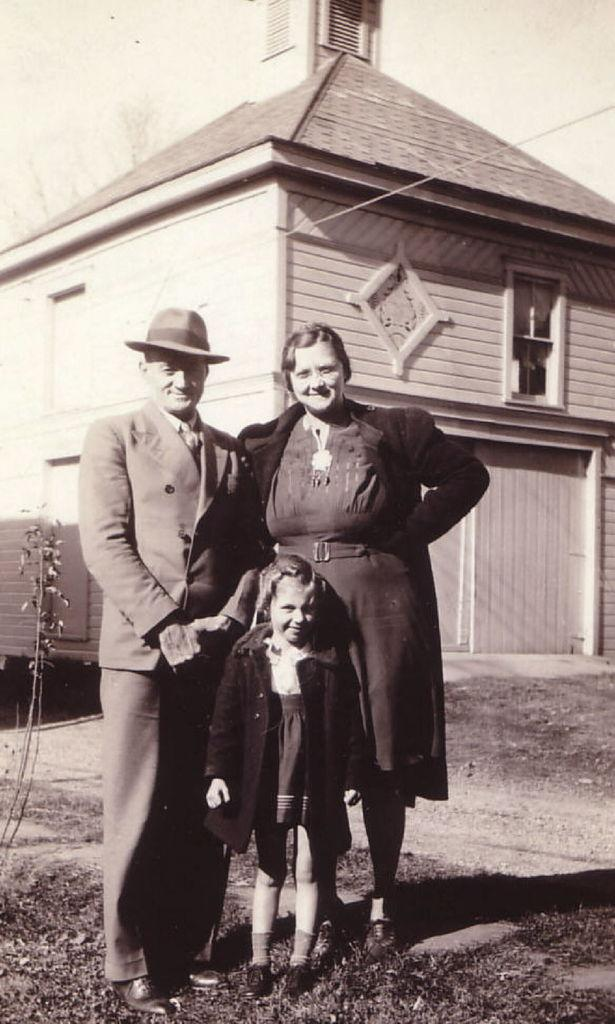What is the main subject of the image? The main subject of the image is a photo. Who or what can be seen in the photo? There is a man, a woman, and a kid in the photo. What are the people in the photo doing? The people are standing in the photo. What can be seen in the background of the photo? There is a house in the background of the photo. What type of lock is used to secure the house in the photo? There is no lock visible in the photo, as it only shows a house in the background. 